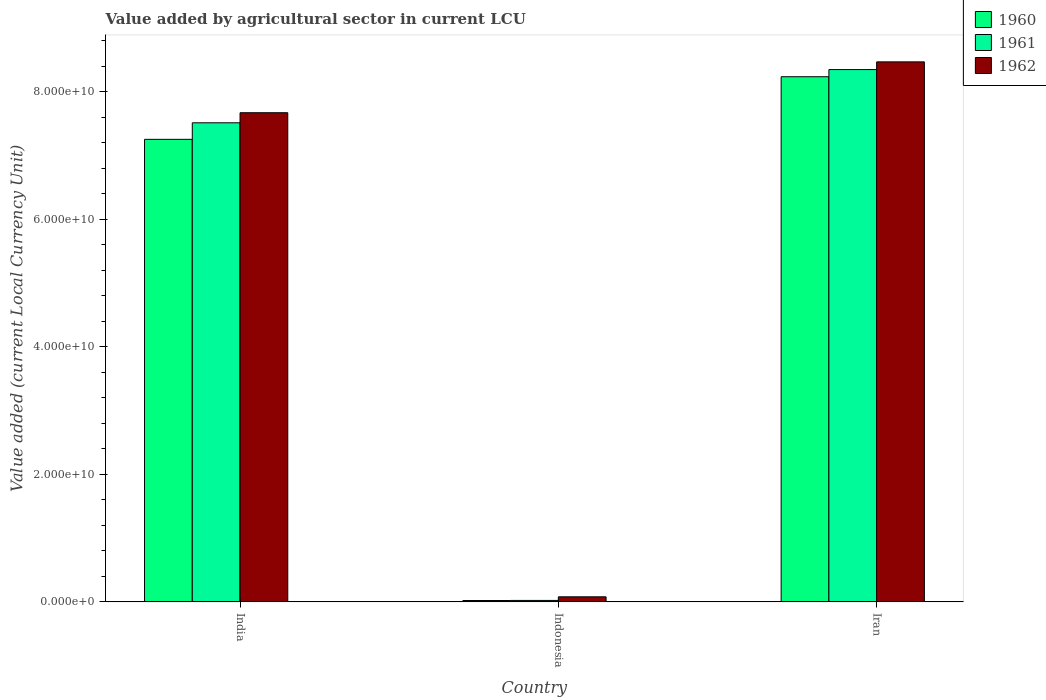How many different coloured bars are there?
Provide a succinct answer. 3. Are the number of bars on each tick of the X-axis equal?
Give a very brief answer. Yes. How many bars are there on the 2nd tick from the right?
Your answer should be compact. 3. What is the label of the 3rd group of bars from the left?
Give a very brief answer. Iran. What is the value added by agricultural sector in 1961 in Iran?
Ensure brevity in your answer.  8.35e+1. Across all countries, what is the maximum value added by agricultural sector in 1960?
Provide a short and direct response. 8.24e+1. Across all countries, what is the minimum value added by agricultural sector in 1960?
Provide a short and direct response. 2.12e+08. In which country was the value added by agricultural sector in 1961 maximum?
Provide a short and direct response. Iran. What is the total value added by agricultural sector in 1960 in the graph?
Your answer should be compact. 1.55e+11. What is the difference between the value added by agricultural sector in 1962 in Indonesia and that in Iran?
Offer a very short reply. -8.39e+1. What is the difference between the value added by agricultural sector in 1961 in Iran and the value added by agricultural sector in 1960 in Indonesia?
Give a very brief answer. 8.33e+1. What is the average value added by agricultural sector in 1961 per country?
Give a very brief answer. 5.30e+1. What is the difference between the value added by agricultural sector of/in 1961 and value added by agricultural sector of/in 1962 in Indonesia?
Give a very brief answer. -5.66e+08. What is the ratio of the value added by agricultural sector in 1960 in India to that in Iran?
Provide a succinct answer. 0.88. Is the value added by agricultural sector in 1960 in India less than that in Iran?
Your answer should be compact. Yes. Is the difference between the value added by agricultural sector in 1961 in Indonesia and Iran greater than the difference between the value added by agricultural sector in 1962 in Indonesia and Iran?
Your answer should be very brief. Yes. What is the difference between the highest and the second highest value added by agricultural sector in 1962?
Ensure brevity in your answer.  -7.98e+09. What is the difference between the highest and the lowest value added by agricultural sector in 1961?
Your response must be concise. 8.33e+1. In how many countries, is the value added by agricultural sector in 1960 greater than the average value added by agricultural sector in 1960 taken over all countries?
Provide a succinct answer. 2. Is it the case that in every country, the sum of the value added by agricultural sector in 1960 and value added by agricultural sector in 1961 is greater than the value added by agricultural sector in 1962?
Make the answer very short. No. Are all the bars in the graph horizontal?
Provide a succinct answer. No. How many countries are there in the graph?
Offer a terse response. 3. Does the graph contain any zero values?
Give a very brief answer. No. Where does the legend appear in the graph?
Give a very brief answer. Top right. How many legend labels are there?
Your answer should be very brief. 3. How are the legend labels stacked?
Give a very brief answer. Vertical. What is the title of the graph?
Your response must be concise. Value added by agricultural sector in current LCU. What is the label or title of the Y-axis?
Provide a short and direct response. Value added (current Local Currency Unit). What is the Value added (current Local Currency Unit) in 1960 in India?
Your answer should be compact. 7.26e+1. What is the Value added (current Local Currency Unit) in 1961 in India?
Provide a short and direct response. 7.52e+1. What is the Value added (current Local Currency Unit) in 1962 in India?
Ensure brevity in your answer.  7.67e+1. What is the Value added (current Local Currency Unit) in 1960 in Indonesia?
Make the answer very short. 2.12e+08. What is the Value added (current Local Currency Unit) in 1961 in Indonesia?
Provide a succinct answer. 2.27e+08. What is the Value added (current Local Currency Unit) in 1962 in Indonesia?
Give a very brief answer. 7.93e+08. What is the Value added (current Local Currency Unit) in 1960 in Iran?
Provide a short and direct response. 8.24e+1. What is the Value added (current Local Currency Unit) in 1961 in Iran?
Ensure brevity in your answer.  8.35e+1. What is the Value added (current Local Currency Unit) in 1962 in Iran?
Provide a short and direct response. 8.47e+1. Across all countries, what is the maximum Value added (current Local Currency Unit) in 1960?
Provide a succinct answer. 8.24e+1. Across all countries, what is the maximum Value added (current Local Currency Unit) of 1961?
Make the answer very short. 8.35e+1. Across all countries, what is the maximum Value added (current Local Currency Unit) of 1962?
Offer a terse response. 8.47e+1. Across all countries, what is the minimum Value added (current Local Currency Unit) in 1960?
Keep it short and to the point. 2.12e+08. Across all countries, what is the minimum Value added (current Local Currency Unit) in 1961?
Provide a succinct answer. 2.27e+08. Across all countries, what is the minimum Value added (current Local Currency Unit) in 1962?
Give a very brief answer. 7.93e+08. What is the total Value added (current Local Currency Unit) of 1960 in the graph?
Ensure brevity in your answer.  1.55e+11. What is the total Value added (current Local Currency Unit) of 1961 in the graph?
Your answer should be very brief. 1.59e+11. What is the total Value added (current Local Currency Unit) in 1962 in the graph?
Offer a very short reply. 1.62e+11. What is the difference between the Value added (current Local Currency Unit) of 1960 in India and that in Indonesia?
Offer a very short reply. 7.24e+1. What is the difference between the Value added (current Local Currency Unit) of 1961 in India and that in Indonesia?
Make the answer very short. 7.49e+1. What is the difference between the Value added (current Local Currency Unit) in 1962 in India and that in Indonesia?
Provide a succinct answer. 7.59e+1. What is the difference between the Value added (current Local Currency Unit) of 1960 in India and that in Iran?
Give a very brief answer. -9.82e+09. What is the difference between the Value added (current Local Currency Unit) of 1961 in India and that in Iran?
Offer a terse response. -8.35e+09. What is the difference between the Value added (current Local Currency Unit) in 1962 in India and that in Iran?
Offer a terse response. -7.98e+09. What is the difference between the Value added (current Local Currency Unit) of 1960 in Indonesia and that in Iran?
Your answer should be compact. -8.22e+1. What is the difference between the Value added (current Local Currency Unit) in 1961 in Indonesia and that in Iran?
Your answer should be compact. -8.33e+1. What is the difference between the Value added (current Local Currency Unit) in 1962 in Indonesia and that in Iran?
Your response must be concise. -8.39e+1. What is the difference between the Value added (current Local Currency Unit) in 1960 in India and the Value added (current Local Currency Unit) in 1961 in Indonesia?
Offer a terse response. 7.23e+1. What is the difference between the Value added (current Local Currency Unit) in 1960 in India and the Value added (current Local Currency Unit) in 1962 in Indonesia?
Provide a short and direct response. 7.18e+1. What is the difference between the Value added (current Local Currency Unit) of 1961 in India and the Value added (current Local Currency Unit) of 1962 in Indonesia?
Offer a terse response. 7.44e+1. What is the difference between the Value added (current Local Currency Unit) of 1960 in India and the Value added (current Local Currency Unit) of 1961 in Iran?
Give a very brief answer. -1.09e+1. What is the difference between the Value added (current Local Currency Unit) in 1960 in India and the Value added (current Local Currency Unit) in 1962 in Iran?
Provide a succinct answer. -1.22e+1. What is the difference between the Value added (current Local Currency Unit) in 1961 in India and the Value added (current Local Currency Unit) in 1962 in Iran?
Offer a very short reply. -9.56e+09. What is the difference between the Value added (current Local Currency Unit) of 1960 in Indonesia and the Value added (current Local Currency Unit) of 1961 in Iran?
Provide a succinct answer. -8.33e+1. What is the difference between the Value added (current Local Currency Unit) in 1960 in Indonesia and the Value added (current Local Currency Unit) in 1962 in Iran?
Make the answer very short. -8.45e+1. What is the difference between the Value added (current Local Currency Unit) of 1961 in Indonesia and the Value added (current Local Currency Unit) of 1962 in Iran?
Ensure brevity in your answer.  -8.45e+1. What is the average Value added (current Local Currency Unit) in 1960 per country?
Provide a succinct answer. 5.17e+1. What is the average Value added (current Local Currency Unit) of 1961 per country?
Offer a terse response. 5.30e+1. What is the average Value added (current Local Currency Unit) of 1962 per country?
Provide a short and direct response. 5.41e+1. What is the difference between the Value added (current Local Currency Unit) of 1960 and Value added (current Local Currency Unit) of 1961 in India?
Keep it short and to the point. -2.59e+09. What is the difference between the Value added (current Local Currency Unit) in 1960 and Value added (current Local Currency Unit) in 1962 in India?
Your answer should be compact. -4.17e+09. What is the difference between the Value added (current Local Currency Unit) in 1961 and Value added (current Local Currency Unit) in 1962 in India?
Offer a very short reply. -1.58e+09. What is the difference between the Value added (current Local Currency Unit) in 1960 and Value added (current Local Currency Unit) in 1961 in Indonesia?
Your answer should be compact. -1.50e+07. What is the difference between the Value added (current Local Currency Unit) of 1960 and Value added (current Local Currency Unit) of 1962 in Indonesia?
Your response must be concise. -5.81e+08. What is the difference between the Value added (current Local Currency Unit) of 1961 and Value added (current Local Currency Unit) of 1962 in Indonesia?
Keep it short and to the point. -5.66e+08. What is the difference between the Value added (current Local Currency Unit) in 1960 and Value added (current Local Currency Unit) in 1961 in Iran?
Make the answer very short. -1.12e+09. What is the difference between the Value added (current Local Currency Unit) of 1960 and Value added (current Local Currency Unit) of 1962 in Iran?
Your response must be concise. -2.33e+09. What is the difference between the Value added (current Local Currency Unit) in 1961 and Value added (current Local Currency Unit) in 1962 in Iran?
Keep it short and to the point. -1.21e+09. What is the ratio of the Value added (current Local Currency Unit) in 1960 in India to that in Indonesia?
Provide a succinct answer. 342.29. What is the ratio of the Value added (current Local Currency Unit) of 1961 in India to that in Indonesia?
Your response must be concise. 331.1. What is the ratio of the Value added (current Local Currency Unit) of 1962 in India to that in Indonesia?
Provide a short and direct response. 96.77. What is the ratio of the Value added (current Local Currency Unit) in 1960 in India to that in Iran?
Your answer should be compact. 0.88. What is the ratio of the Value added (current Local Currency Unit) in 1962 in India to that in Iran?
Your response must be concise. 0.91. What is the ratio of the Value added (current Local Currency Unit) in 1960 in Indonesia to that in Iran?
Offer a very short reply. 0. What is the ratio of the Value added (current Local Currency Unit) of 1961 in Indonesia to that in Iran?
Offer a very short reply. 0. What is the ratio of the Value added (current Local Currency Unit) of 1962 in Indonesia to that in Iran?
Offer a very short reply. 0.01. What is the difference between the highest and the second highest Value added (current Local Currency Unit) in 1960?
Keep it short and to the point. 9.82e+09. What is the difference between the highest and the second highest Value added (current Local Currency Unit) in 1961?
Make the answer very short. 8.35e+09. What is the difference between the highest and the second highest Value added (current Local Currency Unit) in 1962?
Ensure brevity in your answer.  7.98e+09. What is the difference between the highest and the lowest Value added (current Local Currency Unit) in 1960?
Provide a succinct answer. 8.22e+1. What is the difference between the highest and the lowest Value added (current Local Currency Unit) in 1961?
Keep it short and to the point. 8.33e+1. What is the difference between the highest and the lowest Value added (current Local Currency Unit) of 1962?
Your answer should be very brief. 8.39e+1. 